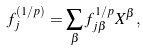<formula> <loc_0><loc_0><loc_500><loc_500>f _ { j } ^ { ( 1 / p ) } = \sum _ { \beta } f _ { j \beta } ^ { 1 / p } X ^ { \beta } ,</formula> 